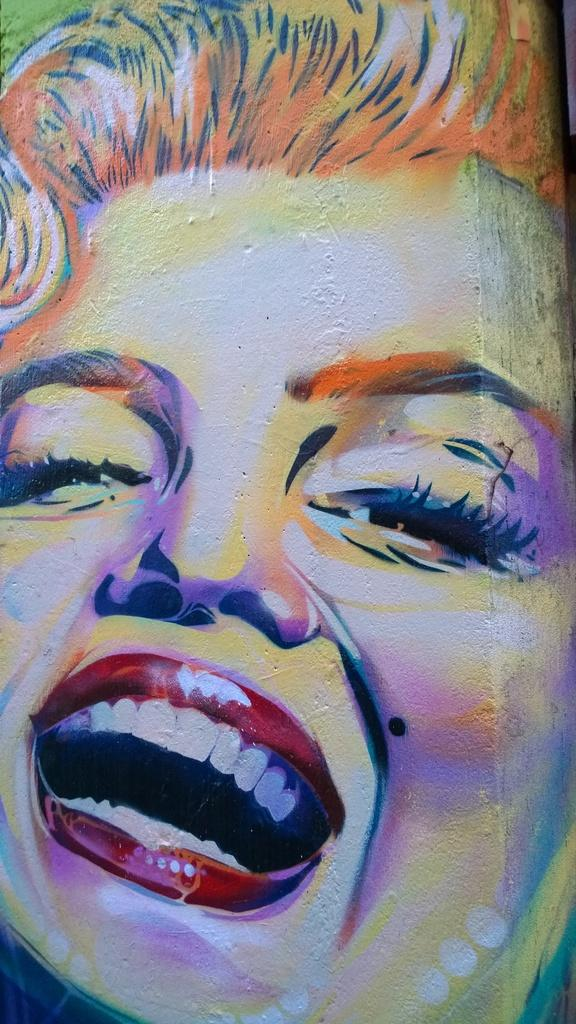What is the main subject of the image? There is a painting in the image. What does the painting depict? The painting depicts the face of a woman. Where is the quill located in the image? There is no quill present in the image; it only features a painting of a woman's face. 